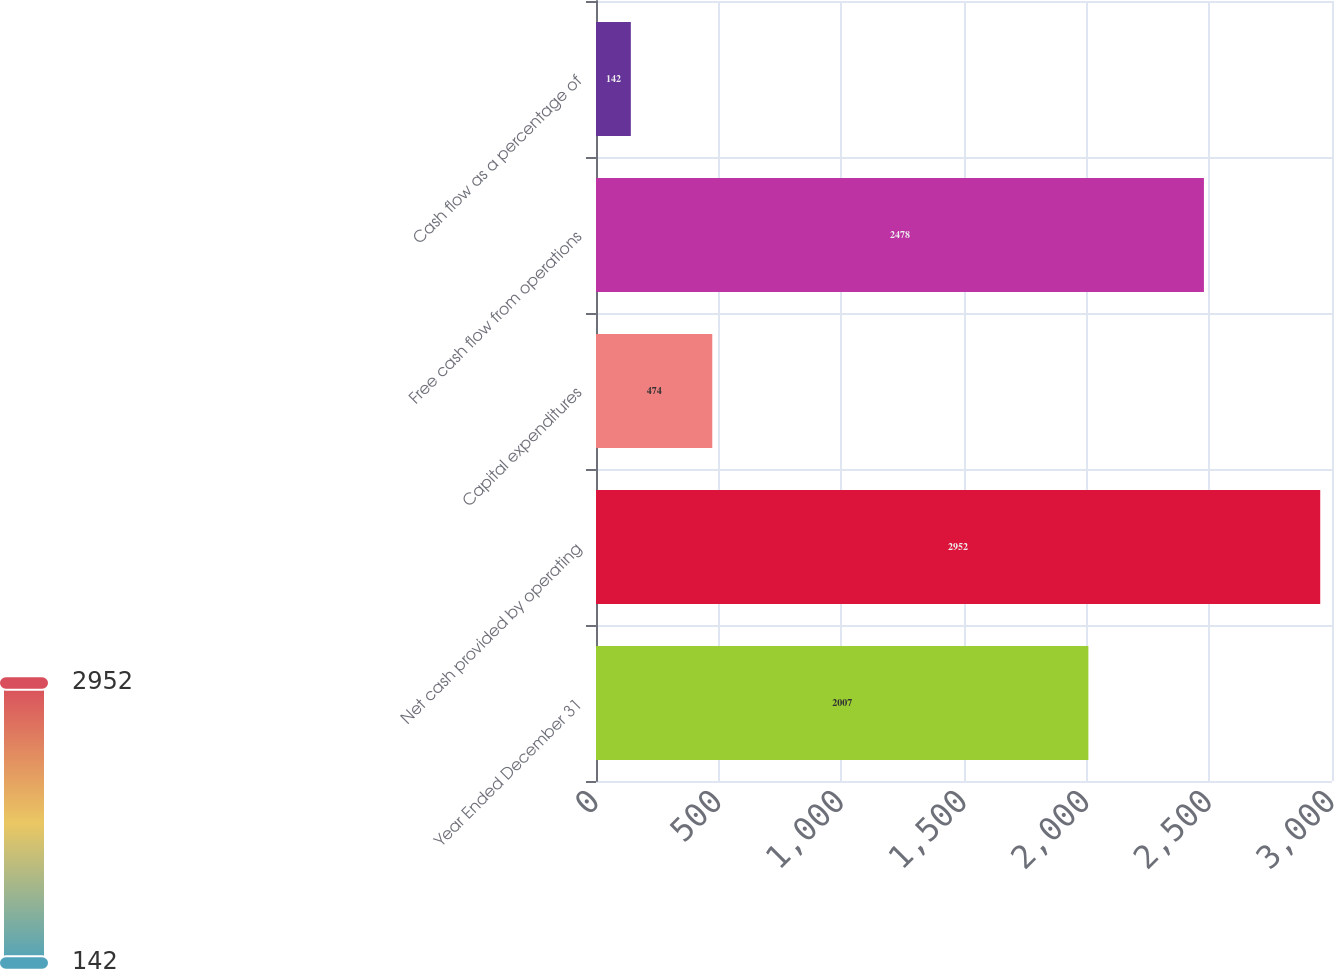Convert chart. <chart><loc_0><loc_0><loc_500><loc_500><bar_chart><fcel>Year Ended December 31<fcel>Net cash provided by operating<fcel>Capital expenditures<fcel>Free cash flow from operations<fcel>Cash flow as a percentage of<nl><fcel>2007<fcel>2952<fcel>474<fcel>2478<fcel>142<nl></chart> 